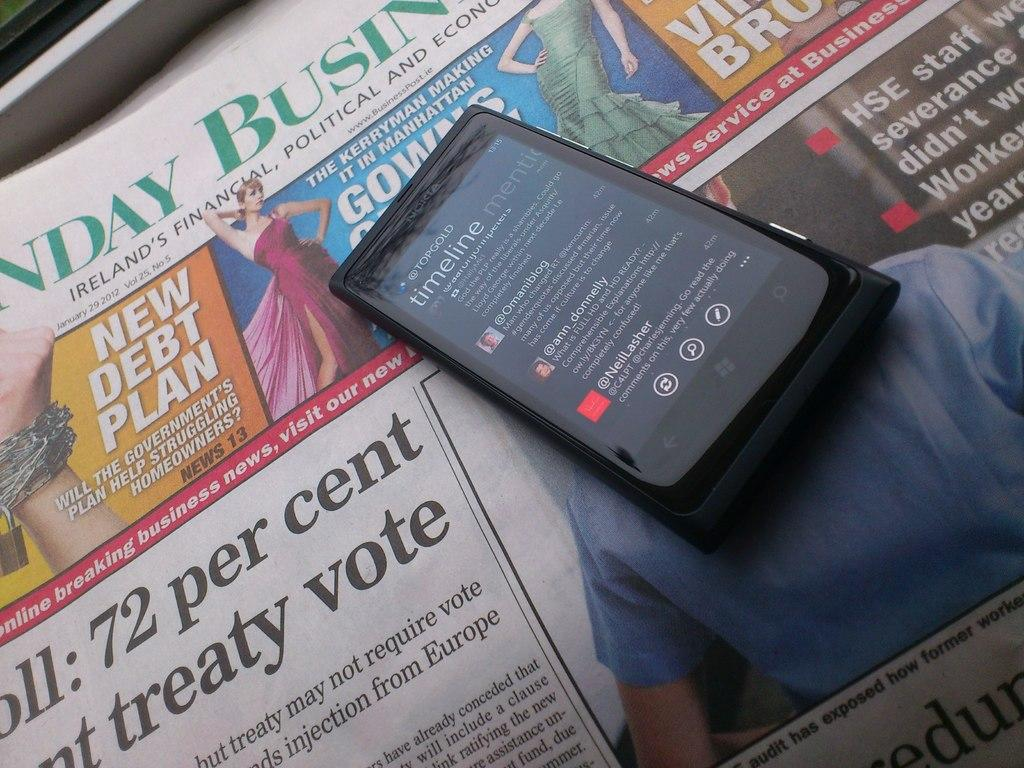<image>
Relay a brief, clear account of the picture shown. A cellphone is on a newspaper called Sunday Business. 